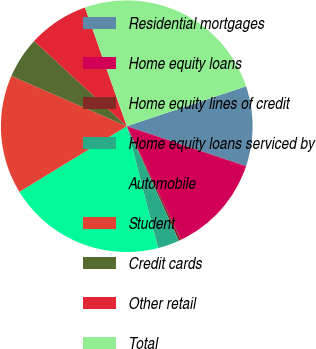Convert chart. <chart><loc_0><loc_0><loc_500><loc_500><pie_chart><fcel>Residential mortgages<fcel>Home equity loans<fcel>Home equity lines of credit<fcel>Home equity loans serviced by<fcel>Automobile<fcel>Student<fcel>Credit cards<fcel>Other retail<fcel>Total<nl><fcel>10.28%<fcel>12.77%<fcel>0.3%<fcel>2.79%<fcel>20.26%<fcel>15.27%<fcel>5.29%<fcel>7.78%<fcel>25.25%<nl></chart> 